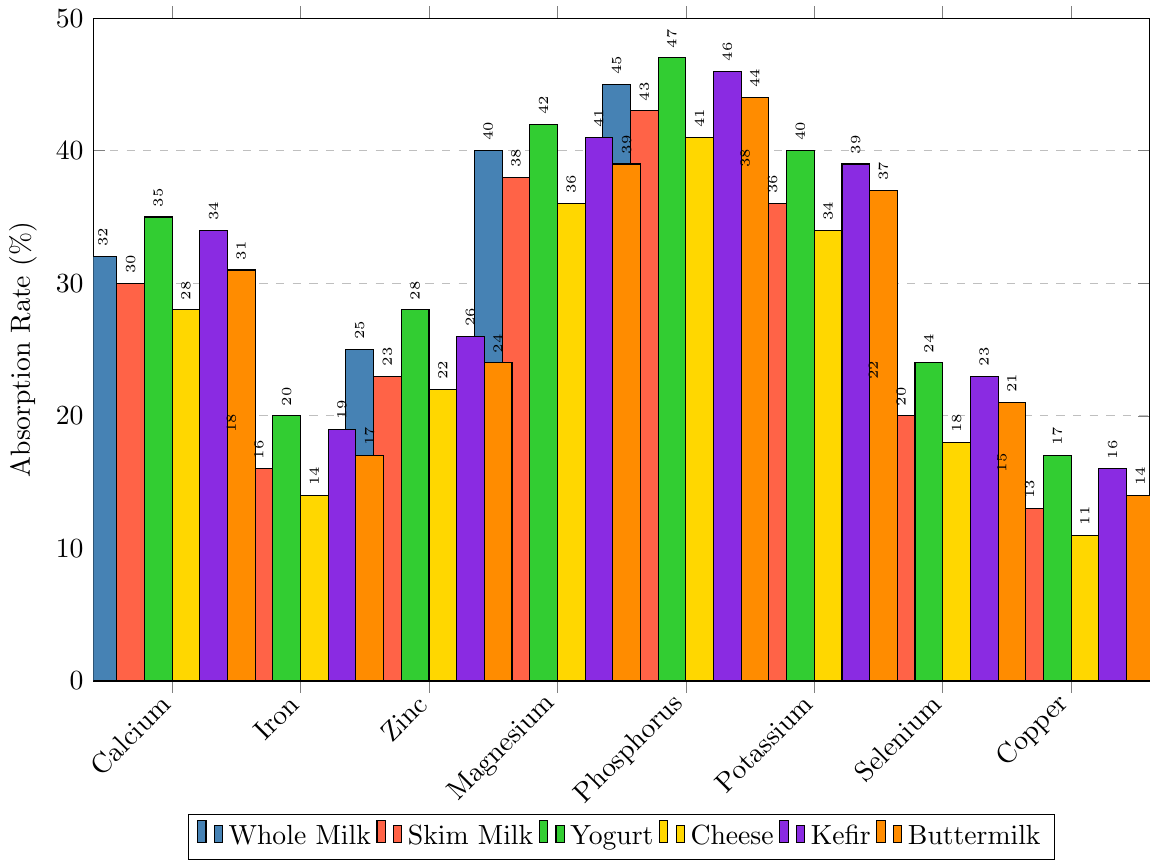Which dairy product has the highest absorption rate for phosphorus? Look for the tallest bar in the "Phosphorus" section. The tallest bar corresponds to yogurt with an absorption rate of 47%.
Answer: Yogurt How much higher is the calcium absorption rate in whole milk compared to cheese? Subtract the calcium absorption rate for cheese (28%) from that of whole milk (32%). 32% - 28% = 4%.
Answer: 4% Which mineral has the lowest absorption rate across all dairy products? Identify the shortest bar among all the minerals. The shortest bar is for copper in cheese, with an absorption rate of 11%.
Answer: Copper What is the average absorption rate of selenium across all dairy products? Sum the selenium absorption rates (22 + 20 + 24 + 18 + 23 + 21) and divide by the number of products (6). (22 + 20 + 24 + 18 + 23 + 21) / 6 = 21.33%.
Answer: 21.33% Which dairy product has the most uniform absorption rates across all minerals? Compare the heights of all bars for each dairy product. Whole milk shows relatively uniform absorption rates, with smaller differences between its highest and lowest values compared to other products.
Answer: Whole Milk Is the absorption rate of zinc higher in yogurt or buttermilk? Compare the heights of the bars for zinc in yogurt and buttermilk. Yogurt (28%) has a higher absorption rate than buttermilk (24%).
Answer: Yogurt What is the difference between the highest and lowest absorption rates for magnesium across all dairy products? Identify the maximum (42% in yogurt) and minimum (36% in cheese) absorption rates for magnesium, and subtract the minimum from the maximum. 42% - 36% = 6%.
Answer: 6% How does the selenium absorption rate in skim milk compare to that in kefir? Compare the heights of the bars for selenium in both skim milk (20%) and kefir (23%). Skim milk's absorption rate is lower by 3%.
Answer: Lower by 3% What is the total sum of absorption rates for potassium in all dairy products? Sum the potassium absorption rates for whole milk (38), skim milk (36), yogurt (40), cheese (34), kefir (39), and buttermilk (37). 38 + 36 + 40 + 34 + 39 + 37 = 224.
Answer: 224 In which dairy product is the absorption rate of copper exactly 17%? Look for the bar with a height of 17% in the "Copper" section. This corresponds to yogurt.
Answer: Yogurt 